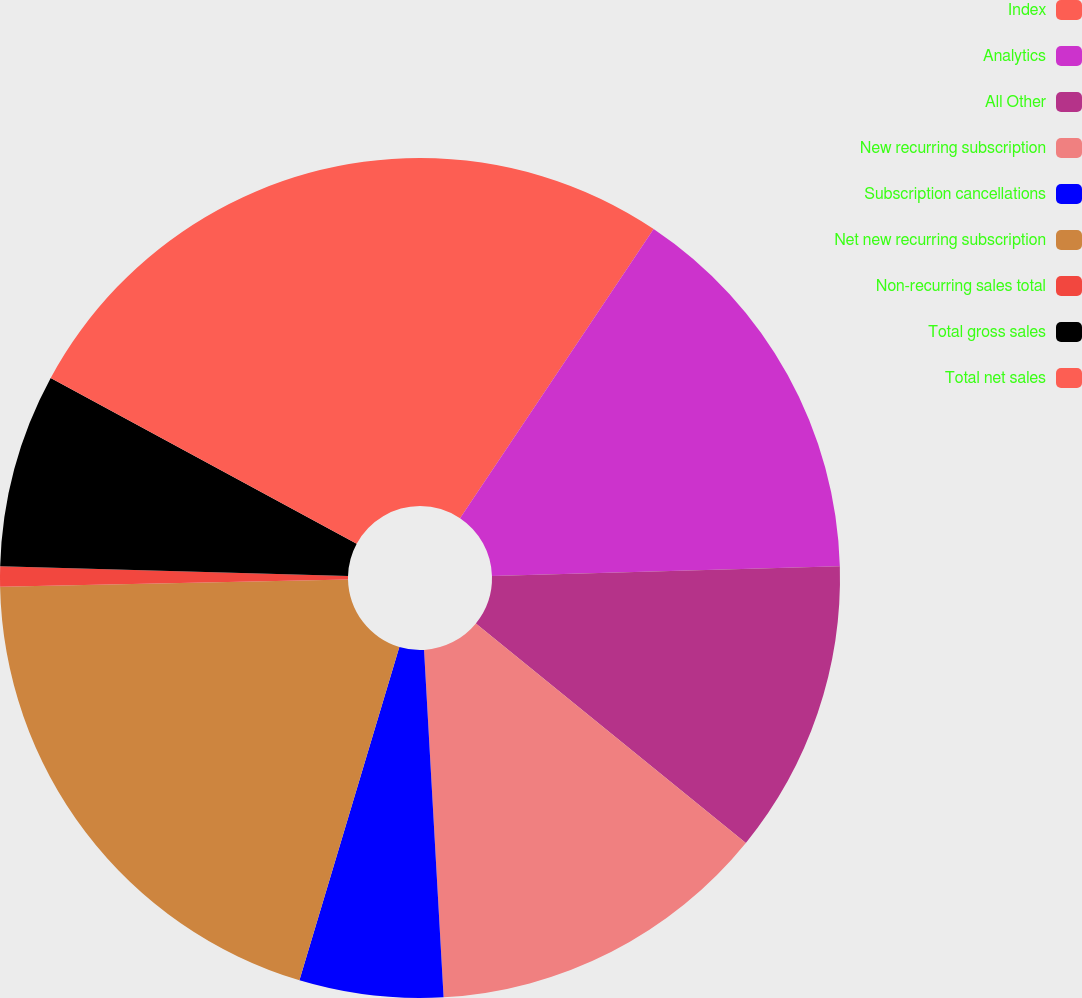<chart> <loc_0><loc_0><loc_500><loc_500><pie_chart><fcel>Index<fcel>Analytics<fcel>All Other<fcel>New recurring subscription<fcel>Subscription cancellations<fcel>Net new recurring subscription<fcel>Non-recurring sales total<fcel>Total gross sales<fcel>Total net sales<nl><fcel>9.39%<fcel>15.17%<fcel>11.31%<fcel>13.24%<fcel>5.53%<fcel>20.04%<fcel>0.77%<fcel>7.46%<fcel>17.1%<nl></chart> 